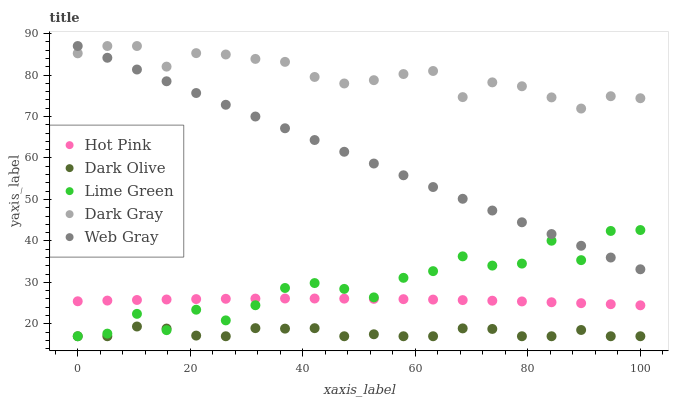Does Dark Olive have the minimum area under the curve?
Answer yes or no. Yes. Does Dark Gray have the maximum area under the curve?
Answer yes or no. Yes. Does Hot Pink have the minimum area under the curve?
Answer yes or no. No. Does Hot Pink have the maximum area under the curve?
Answer yes or no. No. Is Web Gray the smoothest?
Answer yes or no. Yes. Is Lime Green the roughest?
Answer yes or no. Yes. Is Dark Gray the smoothest?
Answer yes or no. No. Is Dark Gray the roughest?
Answer yes or no. No. Does Dark Olive have the lowest value?
Answer yes or no. Yes. Does Hot Pink have the lowest value?
Answer yes or no. No. Does Web Gray have the highest value?
Answer yes or no. Yes. Does Hot Pink have the highest value?
Answer yes or no. No. Is Dark Olive less than Hot Pink?
Answer yes or no. Yes. Is Hot Pink greater than Dark Olive?
Answer yes or no. Yes. Does Lime Green intersect Dark Olive?
Answer yes or no. Yes. Is Lime Green less than Dark Olive?
Answer yes or no. No. Is Lime Green greater than Dark Olive?
Answer yes or no. No. Does Dark Olive intersect Hot Pink?
Answer yes or no. No. 